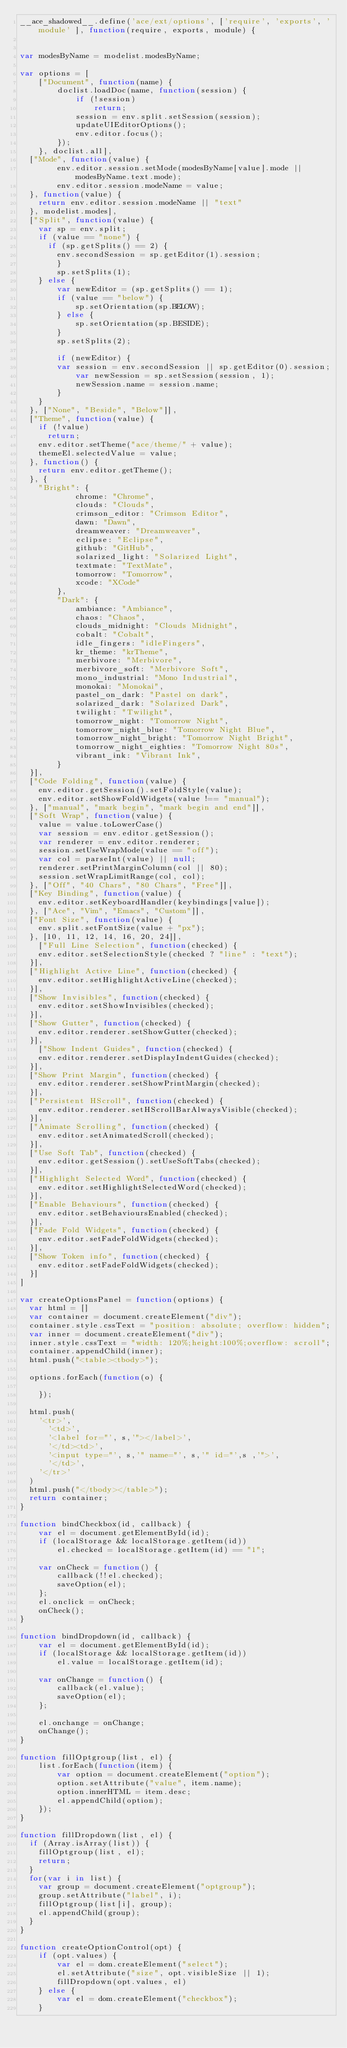<code> <loc_0><loc_0><loc_500><loc_500><_JavaScript_>__ace_shadowed__.define('ace/ext/options', ['require', 'exports', 'module' ], function(require, exports, module) {


var modesByName = modelist.modesByName;

var options = [
    ["Document", function(name) {
        doclist.loadDoc(name, function(session) {
            if (!session)
                return;
            session = env.split.setSession(session);
            updateUIEditorOptions();
            env.editor.focus();
        });
    }, doclist.all],
	["Mode", function(value) {
        env.editor.session.setMode(modesByName[value].mode || modesByName.text.mode);
        env.editor.session.modeName = value;
	}, function(value) {
		return env.editor.session.modeName || "text"
	}, modelist.modes],
	["Split", function(value) {
		var sp = env.split;
		if (value == "none") {
			if (sp.getSplits() == 2) {
				env.secondSession = sp.getEditor(1).session;
        }
        sp.setSplits(1);
    } else {
        var newEditor = (sp.getSplits() == 1);
        if (value == "below") {
            sp.setOrientation(sp.BELOW);
        } else {
            sp.setOrientation(sp.BESIDE);
        }
        sp.setSplits(2);

        if (newEditor) {
				var session = env.secondSession || sp.getEditor(0).session;
            var newSession = sp.setSession(session, 1);
            newSession.name = session.name;
        }
    }
	}, ["None", "Beside", "Below"]],
	["Theme", function(value) {
		if (!value)
			return;
		env.editor.setTheme("ace/theme/" + value);
		themeEl.selectedValue = value;
	}, function() {
		return env.editor.getTheme();
	}, {
		"Bright": {
            chrome: "Chrome",
            clouds: "Clouds",
            crimson_editor: "Crimson Editor",
            dawn: "Dawn",
            dreamweaver: "Dreamweaver",
            eclipse: "Eclipse",
            github: "GitHub",
            solarized_light: "Solarized Light",
            textmate: "TextMate",
            tomorrow: "Tomorrow",
            xcode: "XCode"
        },
        "Dark": {
            ambiance: "Ambiance",
            chaos: "Chaos",
            clouds_midnight: "Clouds Midnight",
            cobalt: "Cobalt",
            idle_fingers: "idleFingers",
            kr_theme: "krTheme",
            merbivore: "Merbivore",
            merbivore_soft: "Merbivore Soft",
            mono_industrial: "Mono Industrial",
            monokai: "Monokai",
            pastel_on_dark: "Pastel on dark",
            solarized_dark: "Solarized Dark",
            twilight: "Twilight",
            tomorrow_night: "Tomorrow Night",
            tomorrow_night_blue: "Tomorrow Night Blue",
            tomorrow_night_bright: "Tomorrow Night Bright",
            tomorrow_night_eighties: "Tomorrow Night 80s",
            vibrant_ink: "Vibrant Ink",
        }
	}],
	["Code Folding", function(value) {
		env.editor.getSession().setFoldStyle(value);
		env.editor.setShowFoldWidgets(value !== "manual");
	}, ["manual", "mark begin", "mark begin and end"]],
	["Soft Wrap", function(value) {
		value = value.toLowerCase()
		var session = env.editor.getSession();
		var renderer = env.editor.renderer;
		session.setUseWrapMode(value == "off");
		var col = parseInt(value) || null;
		renderer.setPrintMarginColumn(col || 80);
		session.setWrapLimitRange(col, col);
	}, ["Off", "40 Chars", "80 Chars", "Free"]],
	["Key Binding", function(value) {
		env.editor.setKeyboardHandler(keybindings[value]);
	}, ["Ace", "Vim", "Emacs", "Custom"]],
	["Font Size", function(value) {
		env.split.setFontSize(value + "px");
	}, [10, 11, 12, 14, 16, 20, 24]],
    ["Full Line Selection", function(checked) {
		env.editor.setSelectionStyle(checked ? "line" : "text");
	}],
	["Highlight Active Line", function(checked) {
		env.editor.setHighlightActiveLine(checked);
	}],
	["Show Invisibles", function(checked) {
		env.editor.setShowInvisibles(checked);
	}],
	["Show Gutter", function(checked) {
		env.editor.renderer.setShowGutter(checked);
	}],
    ["Show Indent Guides", function(checked) {
		env.editor.renderer.setDisplayIndentGuides(checked);
	}],
	["Show Print Margin", function(checked) {
		env.editor.renderer.setShowPrintMargin(checked);
	}],
	["Persistent HScroll", function(checked) {
		env.editor.renderer.setHScrollBarAlwaysVisible(checked);
	}],
	["Animate Scrolling", function(checked) {
		env.editor.setAnimatedScroll(checked);
	}],
	["Use Soft Tab", function(checked) {
		env.editor.getSession().setUseSoftTabs(checked);
	}],
	["Highlight Selected Word", function(checked) {
		env.editor.setHighlightSelectedWord(checked);
	}],
	["Enable Behaviours", function(checked) {
		env.editor.setBehavioursEnabled(checked);
	}],
	["Fade Fold Widgets", function(checked) {
		env.editor.setFadeFoldWidgets(checked);
	}],
	["Show Token info", function(checked) {
		env.editor.setFadeFoldWidgets(checked);
	}]
]

var createOptionsPanel = function(options) {
	var html = []
	var container = document.createElement("div");
	container.style.cssText = "position: absolute; overflow: hidden";
	var inner = document.createElement("div");
	inner.style.cssText = "width: 120%;height:100%;overflow: scroll";
	container.appendChild(inner);
	html.push("<table><tbody>");
	
	options.forEach(function(o) {
		
    });

	html.push(
		'<tr>',
		  '<td>',
			'<label for="', s,'"></label>',
		  '</td><td>',
			'<input type="', s,'" name="', s,'" id="',s ,'">',
		  '</td>',
		'</tr>'
	)
	html.push("</tbody></table>");	
	return container;
}

function bindCheckbox(id, callback) {
    var el = document.getElementById(id);
    if (localStorage && localStorage.getItem(id))
        el.checked = localStorage.getItem(id) == "1";

    var onCheck = function() {
        callback(!!el.checked);
        saveOption(el);
    };
    el.onclick = onCheck;
    onCheck();
}

function bindDropdown(id, callback) {
    var el = document.getElementById(id);
    if (localStorage && localStorage.getItem(id))
        el.value = localStorage.getItem(id);

    var onChange = function() {
        callback(el.value);
        saveOption(el);
    };

    el.onchange = onChange;
    onChange();
}

function fillOptgroup(list, el) {
    list.forEach(function(item) {
        var option = document.createElement("option");
        option.setAttribute("value", item.name);
        option.innerHTML = item.desc;
        el.appendChild(option);
    });
}

function fillDropdown(list, el) {
	if (Array.isArray(list)) {
		fillOptgroup(list, el);
		return;
	}
	for(var i in list) {
		var group = document.createElement("optgroup");
		group.setAttribute("label", i);
		fillOptgroup(list[i], group);
		el.appendChild(group);
	}
}

function createOptionControl(opt) {
    if (opt.values) {
        var el = dom.createElement("select");
        el.setAttribute("size", opt.visibleSize || 1);
        fillDropdown(opt.values, el)        
    } else {
        var el = dom.createElement("checkbox");
    }</code> 